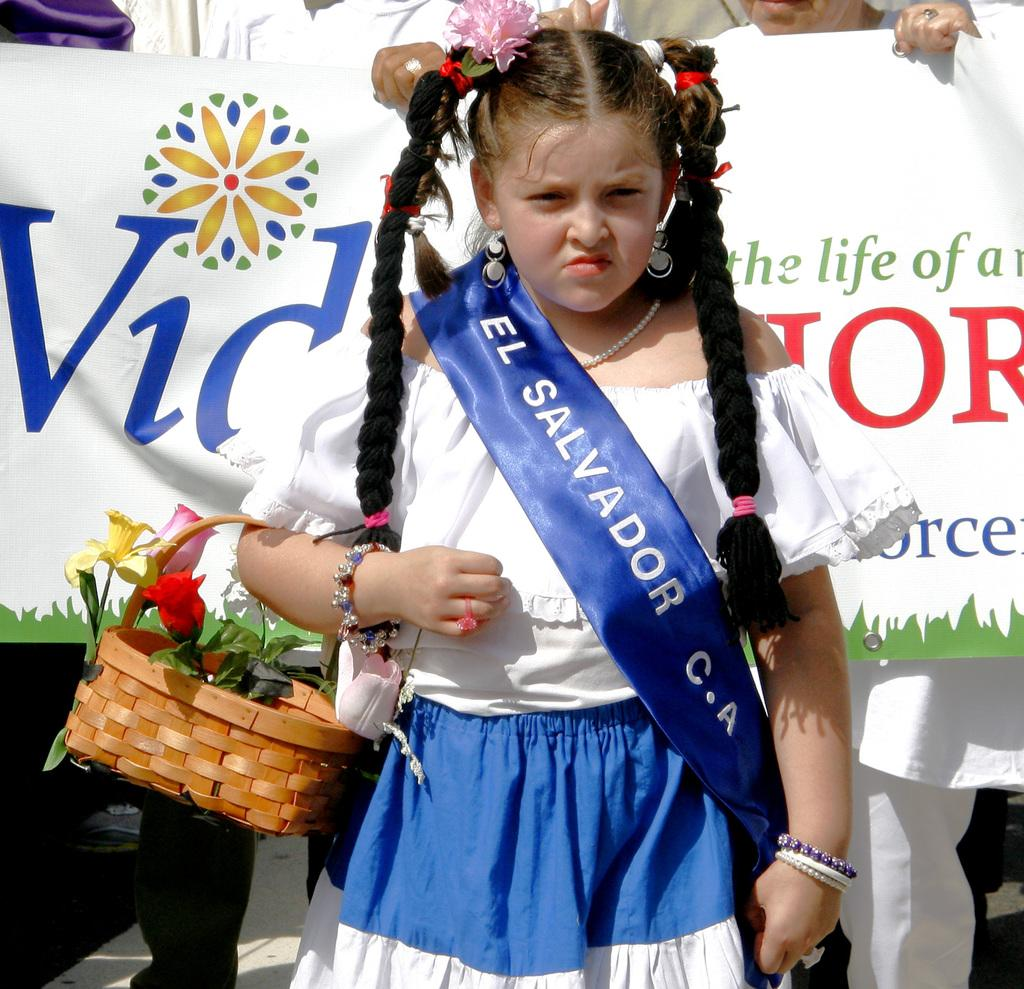<image>
Summarize the visual content of the image. A young girl wearing a dress and sash representing El Salvador C.A. 